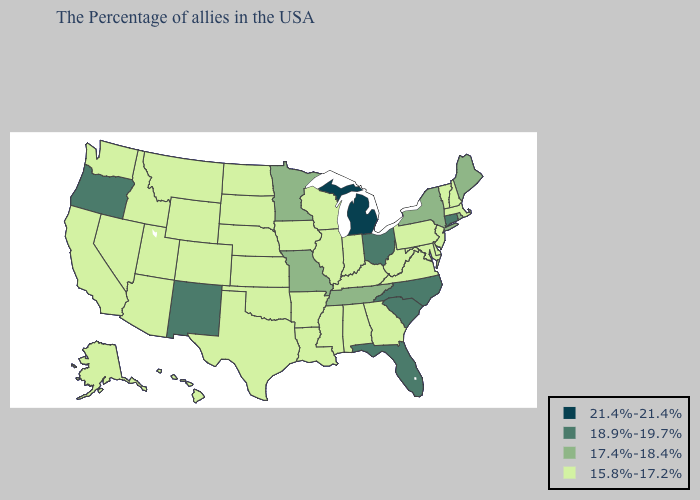Among the states that border Kansas , does Missouri have the highest value?
Quick response, please. Yes. What is the lowest value in the MidWest?
Keep it brief. 15.8%-17.2%. Among the states that border Oklahoma , does New Mexico have the highest value?
Concise answer only. Yes. What is the lowest value in states that border North Dakota?
Give a very brief answer. 15.8%-17.2%. Name the states that have a value in the range 17.4%-18.4%?
Short answer required. Maine, Rhode Island, New York, Tennessee, Missouri, Minnesota. Name the states that have a value in the range 21.4%-21.4%?
Short answer required. Michigan. What is the value of Pennsylvania?
Quick response, please. 15.8%-17.2%. Name the states that have a value in the range 18.9%-19.7%?
Answer briefly. Connecticut, North Carolina, South Carolina, Ohio, Florida, New Mexico, Oregon. Name the states that have a value in the range 15.8%-17.2%?
Write a very short answer. Massachusetts, New Hampshire, Vermont, New Jersey, Delaware, Maryland, Pennsylvania, Virginia, West Virginia, Georgia, Kentucky, Indiana, Alabama, Wisconsin, Illinois, Mississippi, Louisiana, Arkansas, Iowa, Kansas, Nebraska, Oklahoma, Texas, South Dakota, North Dakota, Wyoming, Colorado, Utah, Montana, Arizona, Idaho, Nevada, California, Washington, Alaska, Hawaii. How many symbols are there in the legend?
Answer briefly. 4. Among the states that border Vermont , which have the highest value?
Short answer required. New York. What is the lowest value in states that border New Jersey?
Write a very short answer. 15.8%-17.2%. What is the value of Alabama?
Short answer required. 15.8%-17.2%. Does the first symbol in the legend represent the smallest category?
Give a very brief answer. No. 